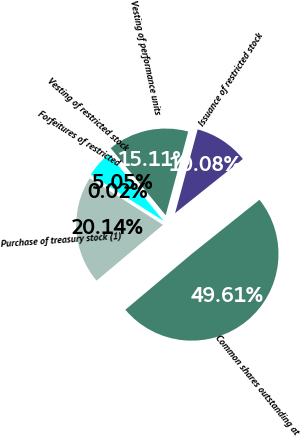<chart> <loc_0><loc_0><loc_500><loc_500><pie_chart><fcel>Common shares outstanding at<fcel>Issuance of restricted stock<fcel>Vesting of performance units<fcel>Vesting of restricted stock<fcel>Forfeitures of restricted<fcel>Purchase of treasury stock (1)<nl><fcel>49.61%<fcel>10.08%<fcel>15.11%<fcel>5.05%<fcel>0.02%<fcel>20.14%<nl></chart> 